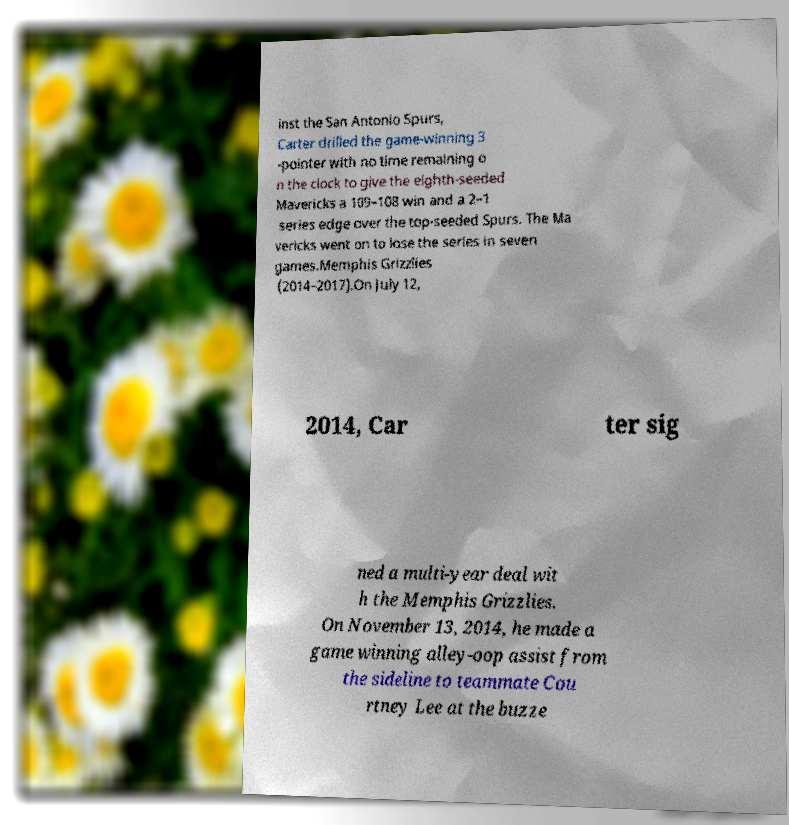Could you assist in decoding the text presented in this image and type it out clearly? inst the San Antonio Spurs, Carter drilled the game-winning 3 -pointer with no time remaining o n the clock to give the eighth-seeded Mavericks a 109–108 win and a 2–1 series edge over the top-seeded Spurs. The Ma vericks went on to lose the series in seven games.Memphis Grizzlies (2014–2017).On July 12, 2014, Car ter sig ned a multi-year deal wit h the Memphis Grizzlies. On November 13, 2014, he made a game winning alley-oop assist from the sideline to teammate Cou rtney Lee at the buzze 